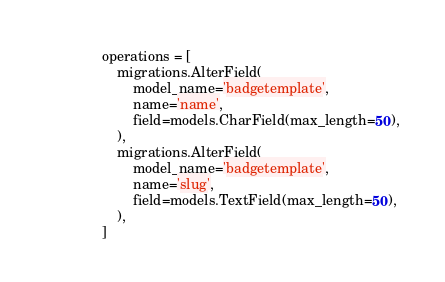<code> <loc_0><loc_0><loc_500><loc_500><_Python_>
    operations = [
        migrations.AlterField(
            model_name='badgetemplate',
            name='name',
            field=models.CharField(max_length=50),
        ),
        migrations.AlterField(
            model_name='badgetemplate',
            name='slug',
            field=models.TextField(max_length=50),
        ),
    ]
</code> 